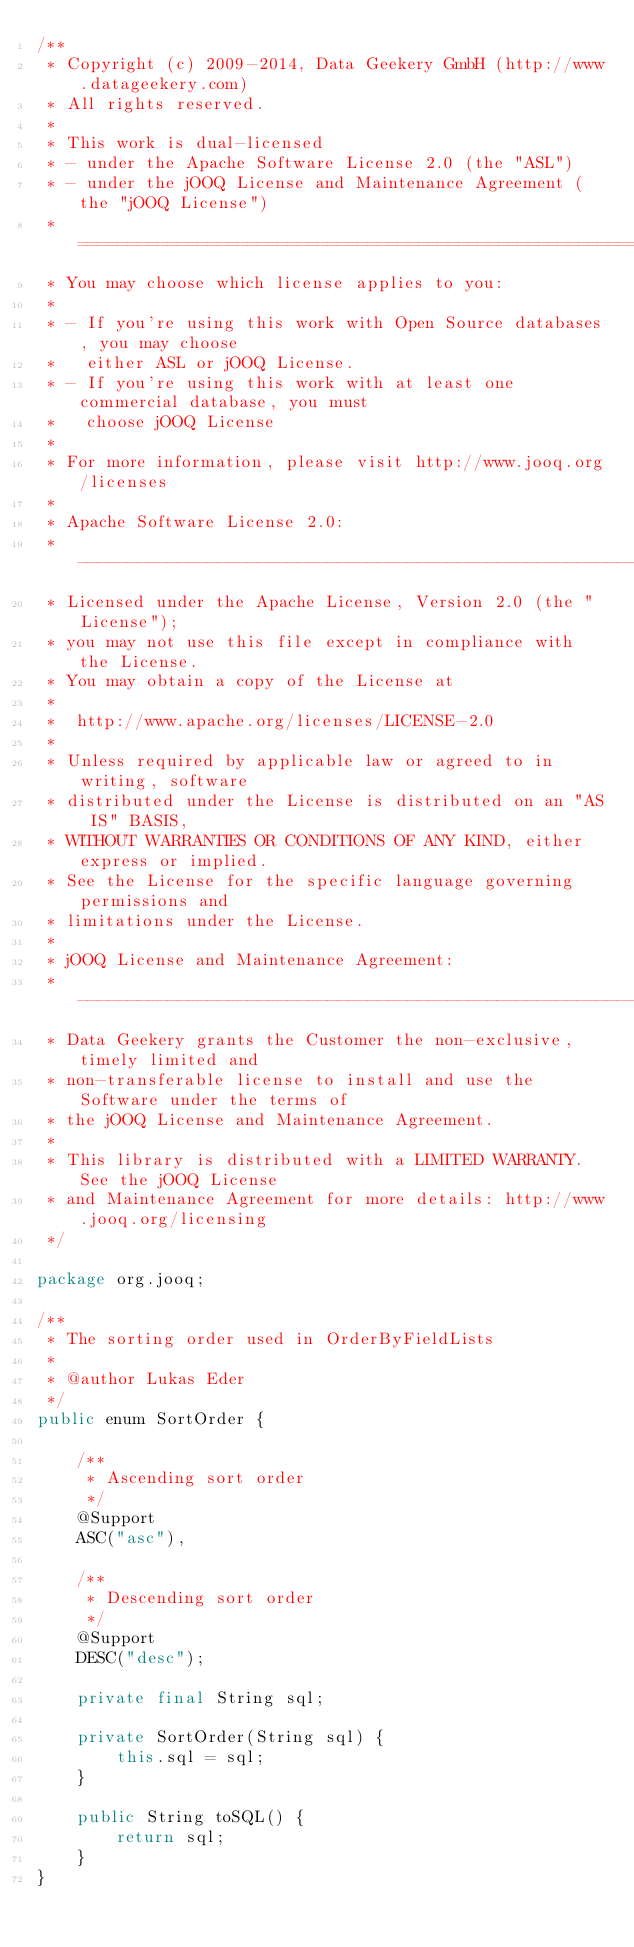<code> <loc_0><loc_0><loc_500><loc_500><_Java_>/**
 * Copyright (c) 2009-2014, Data Geekery GmbH (http://www.datageekery.com)
 * All rights reserved.
 *
 * This work is dual-licensed
 * - under the Apache Software License 2.0 (the "ASL")
 * - under the jOOQ License and Maintenance Agreement (the "jOOQ License")
 * =============================================================================
 * You may choose which license applies to you:
 *
 * - If you're using this work with Open Source databases, you may choose
 *   either ASL or jOOQ License.
 * - If you're using this work with at least one commercial database, you must
 *   choose jOOQ License
 *
 * For more information, please visit http://www.jooq.org/licenses
 *
 * Apache Software License 2.0:
 * -----------------------------------------------------------------------------
 * Licensed under the Apache License, Version 2.0 (the "License");
 * you may not use this file except in compliance with the License.
 * You may obtain a copy of the License at
 *
 *  http://www.apache.org/licenses/LICENSE-2.0
 *
 * Unless required by applicable law or agreed to in writing, software
 * distributed under the License is distributed on an "AS IS" BASIS,
 * WITHOUT WARRANTIES OR CONDITIONS OF ANY KIND, either express or implied.
 * See the License for the specific language governing permissions and
 * limitations under the License.
 *
 * jOOQ License and Maintenance Agreement:
 * -----------------------------------------------------------------------------
 * Data Geekery grants the Customer the non-exclusive, timely limited and
 * non-transferable license to install and use the Software under the terms of
 * the jOOQ License and Maintenance Agreement.
 *
 * This library is distributed with a LIMITED WARRANTY. See the jOOQ License
 * and Maintenance Agreement for more details: http://www.jooq.org/licensing
 */

package org.jooq;

/**
 * The sorting order used in OrderByFieldLists
 *
 * @author Lukas Eder
 */
public enum SortOrder {

    /**
     * Ascending sort order
     */
    @Support
    ASC("asc"),

    /**
     * Descending sort order
     */
    @Support
    DESC("desc");

    private final String sql;

    private SortOrder(String sql) {
        this.sql = sql;
    }

    public String toSQL() {
        return sql;
    }
}
</code> 